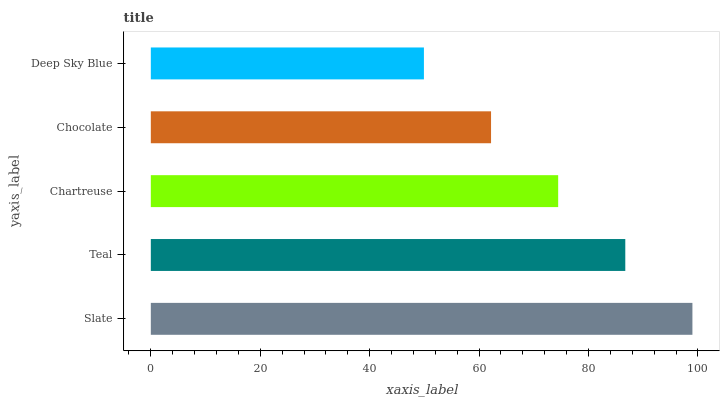Is Deep Sky Blue the minimum?
Answer yes or no. Yes. Is Slate the maximum?
Answer yes or no. Yes. Is Teal the minimum?
Answer yes or no. No. Is Teal the maximum?
Answer yes or no. No. Is Slate greater than Teal?
Answer yes or no. Yes. Is Teal less than Slate?
Answer yes or no. Yes. Is Teal greater than Slate?
Answer yes or no. No. Is Slate less than Teal?
Answer yes or no. No. Is Chartreuse the high median?
Answer yes or no. Yes. Is Chartreuse the low median?
Answer yes or no. Yes. Is Chocolate the high median?
Answer yes or no. No. Is Chocolate the low median?
Answer yes or no. No. 